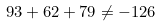<formula> <loc_0><loc_0><loc_500><loc_500>9 3 + 6 2 + 7 9 \neq - 1 2 6</formula> 